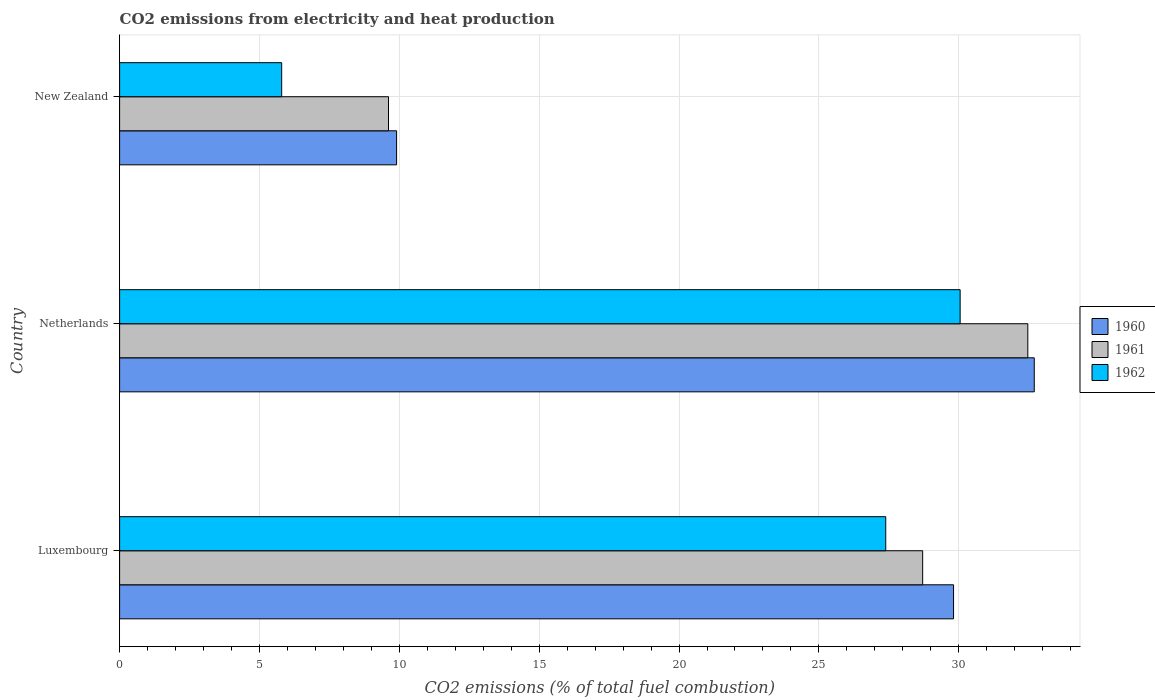How many bars are there on the 2nd tick from the top?
Make the answer very short. 3. What is the amount of CO2 emitted in 1960 in Netherlands?
Offer a very short reply. 32.7. Across all countries, what is the maximum amount of CO2 emitted in 1961?
Your answer should be very brief. 32.47. Across all countries, what is the minimum amount of CO2 emitted in 1962?
Make the answer very short. 5.79. In which country was the amount of CO2 emitted in 1962 minimum?
Make the answer very short. New Zealand. What is the total amount of CO2 emitted in 1962 in the graph?
Provide a short and direct response. 63.23. What is the difference between the amount of CO2 emitted in 1960 in Netherlands and that in New Zealand?
Your answer should be very brief. 22.8. What is the difference between the amount of CO2 emitted in 1960 in New Zealand and the amount of CO2 emitted in 1962 in Netherlands?
Your response must be concise. -20.15. What is the average amount of CO2 emitted in 1961 per country?
Provide a short and direct response. 23.6. What is the difference between the amount of CO2 emitted in 1962 and amount of CO2 emitted in 1960 in New Zealand?
Make the answer very short. -4.11. What is the ratio of the amount of CO2 emitted in 1960 in Netherlands to that in New Zealand?
Provide a short and direct response. 3.3. Is the difference between the amount of CO2 emitted in 1962 in Netherlands and New Zealand greater than the difference between the amount of CO2 emitted in 1960 in Netherlands and New Zealand?
Ensure brevity in your answer.  Yes. What is the difference between the highest and the second highest amount of CO2 emitted in 1960?
Your answer should be very brief. 2.89. What is the difference between the highest and the lowest amount of CO2 emitted in 1960?
Your response must be concise. 22.8. What does the 3rd bar from the top in New Zealand represents?
Make the answer very short. 1960. Is it the case that in every country, the sum of the amount of CO2 emitted in 1962 and amount of CO2 emitted in 1960 is greater than the amount of CO2 emitted in 1961?
Offer a terse response. Yes. How many bars are there?
Offer a terse response. 9. What is the difference between two consecutive major ticks on the X-axis?
Provide a short and direct response. 5. What is the title of the graph?
Make the answer very short. CO2 emissions from electricity and heat production. What is the label or title of the X-axis?
Keep it short and to the point. CO2 emissions (% of total fuel combustion). What is the label or title of the Y-axis?
Keep it short and to the point. Country. What is the CO2 emissions (% of total fuel combustion) of 1960 in Luxembourg?
Provide a short and direct response. 29.81. What is the CO2 emissions (% of total fuel combustion) in 1961 in Luxembourg?
Provide a succinct answer. 28.71. What is the CO2 emissions (% of total fuel combustion) in 1962 in Luxembourg?
Provide a short and direct response. 27.39. What is the CO2 emissions (% of total fuel combustion) in 1960 in Netherlands?
Make the answer very short. 32.7. What is the CO2 emissions (% of total fuel combustion) of 1961 in Netherlands?
Provide a succinct answer. 32.47. What is the CO2 emissions (% of total fuel combustion) of 1962 in Netherlands?
Provide a short and direct response. 30.05. What is the CO2 emissions (% of total fuel combustion) in 1960 in New Zealand?
Ensure brevity in your answer.  9.9. What is the CO2 emissions (% of total fuel combustion) of 1961 in New Zealand?
Ensure brevity in your answer.  9.61. What is the CO2 emissions (% of total fuel combustion) of 1962 in New Zealand?
Your response must be concise. 5.79. Across all countries, what is the maximum CO2 emissions (% of total fuel combustion) of 1960?
Keep it short and to the point. 32.7. Across all countries, what is the maximum CO2 emissions (% of total fuel combustion) in 1961?
Provide a short and direct response. 32.47. Across all countries, what is the maximum CO2 emissions (% of total fuel combustion) in 1962?
Provide a succinct answer. 30.05. Across all countries, what is the minimum CO2 emissions (% of total fuel combustion) in 1960?
Make the answer very short. 9.9. Across all countries, what is the minimum CO2 emissions (% of total fuel combustion) of 1961?
Give a very brief answer. 9.61. Across all countries, what is the minimum CO2 emissions (% of total fuel combustion) of 1962?
Offer a very short reply. 5.79. What is the total CO2 emissions (% of total fuel combustion) of 1960 in the graph?
Your response must be concise. 72.42. What is the total CO2 emissions (% of total fuel combustion) in 1961 in the graph?
Provide a succinct answer. 70.79. What is the total CO2 emissions (% of total fuel combustion) in 1962 in the graph?
Provide a succinct answer. 63.23. What is the difference between the CO2 emissions (% of total fuel combustion) of 1960 in Luxembourg and that in Netherlands?
Your response must be concise. -2.89. What is the difference between the CO2 emissions (% of total fuel combustion) of 1961 in Luxembourg and that in Netherlands?
Your response must be concise. -3.76. What is the difference between the CO2 emissions (% of total fuel combustion) in 1962 in Luxembourg and that in Netherlands?
Provide a succinct answer. -2.66. What is the difference between the CO2 emissions (% of total fuel combustion) of 1960 in Luxembourg and that in New Zealand?
Provide a short and direct response. 19.91. What is the difference between the CO2 emissions (% of total fuel combustion) in 1961 in Luxembourg and that in New Zealand?
Your response must be concise. 19.1. What is the difference between the CO2 emissions (% of total fuel combustion) of 1962 in Luxembourg and that in New Zealand?
Your response must be concise. 21.6. What is the difference between the CO2 emissions (% of total fuel combustion) in 1960 in Netherlands and that in New Zealand?
Offer a very short reply. 22.8. What is the difference between the CO2 emissions (% of total fuel combustion) of 1961 in Netherlands and that in New Zealand?
Ensure brevity in your answer.  22.86. What is the difference between the CO2 emissions (% of total fuel combustion) in 1962 in Netherlands and that in New Zealand?
Make the answer very short. 24.26. What is the difference between the CO2 emissions (% of total fuel combustion) in 1960 in Luxembourg and the CO2 emissions (% of total fuel combustion) in 1961 in Netherlands?
Offer a very short reply. -2.66. What is the difference between the CO2 emissions (% of total fuel combustion) in 1960 in Luxembourg and the CO2 emissions (% of total fuel combustion) in 1962 in Netherlands?
Your response must be concise. -0.24. What is the difference between the CO2 emissions (% of total fuel combustion) of 1961 in Luxembourg and the CO2 emissions (% of total fuel combustion) of 1962 in Netherlands?
Provide a short and direct response. -1.34. What is the difference between the CO2 emissions (% of total fuel combustion) in 1960 in Luxembourg and the CO2 emissions (% of total fuel combustion) in 1961 in New Zealand?
Offer a very short reply. 20.2. What is the difference between the CO2 emissions (% of total fuel combustion) of 1960 in Luxembourg and the CO2 emissions (% of total fuel combustion) of 1962 in New Zealand?
Make the answer very short. 24.02. What is the difference between the CO2 emissions (% of total fuel combustion) in 1961 in Luxembourg and the CO2 emissions (% of total fuel combustion) in 1962 in New Zealand?
Your answer should be very brief. 22.92. What is the difference between the CO2 emissions (% of total fuel combustion) of 1960 in Netherlands and the CO2 emissions (% of total fuel combustion) of 1961 in New Zealand?
Give a very brief answer. 23.09. What is the difference between the CO2 emissions (% of total fuel combustion) of 1960 in Netherlands and the CO2 emissions (% of total fuel combustion) of 1962 in New Zealand?
Your response must be concise. 26.91. What is the difference between the CO2 emissions (% of total fuel combustion) in 1961 in Netherlands and the CO2 emissions (% of total fuel combustion) in 1962 in New Zealand?
Keep it short and to the point. 26.68. What is the average CO2 emissions (% of total fuel combustion) in 1960 per country?
Offer a very short reply. 24.14. What is the average CO2 emissions (% of total fuel combustion) of 1961 per country?
Ensure brevity in your answer.  23.6. What is the average CO2 emissions (% of total fuel combustion) in 1962 per country?
Your response must be concise. 21.08. What is the difference between the CO2 emissions (% of total fuel combustion) in 1960 and CO2 emissions (% of total fuel combustion) in 1961 in Luxembourg?
Provide a succinct answer. 1.1. What is the difference between the CO2 emissions (% of total fuel combustion) in 1960 and CO2 emissions (% of total fuel combustion) in 1962 in Luxembourg?
Your response must be concise. 2.42. What is the difference between the CO2 emissions (% of total fuel combustion) in 1961 and CO2 emissions (% of total fuel combustion) in 1962 in Luxembourg?
Keep it short and to the point. 1.32. What is the difference between the CO2 emissions (% of total fuel combustion) in 1960 and CO2 emissions (% of total fuel combustion) in 1961 in Netherlands?
Your response must be concise. 0.23. What is the difference between the CO2 emissions (% of total fuel combustion) of 1960 and CO2 emissions (% of total fuel combustion) of 1962 in Netherlands?
Your response must be concise. 2.65. What is the difference between the CO2 emissions (% of total fuel combustion) in 1961 and CO2 emissions (% of total fuel combustion) in 1962 in Netherlands?
Ensure brevity in your answer.  2.42. What is the difference between the CO2 emissions (% of total fuel combustion) in 1960 and CO2 emissions (% of total fuel combustion) in 1961 in New Zealand?
Provide a short and direct response. 0.29. What is the difference between the CO2 emissions (% of total fuel combustion) of 1960 and CO2 emissions (% of total fuel combustion) of 1962 in New Zealand?
Keep it short and to the point. 4.11. What is the difference between the CO2 emissions (% of total fuel combustion) in 1961 and CO2 emissions (% of total fuel combustion) in 1962 in New Zealand?
Offer a very short reply. 3.82. What is the ratio of the CO2 emissions (% of total fuel combustion) of 1960 in Luxembourg to that in Netherlands?
Offer a terse response. 0.91. What is the ratio of the CO2 emissions (% of total fuel combustion) of 1961 in Luxembourg to that in Netherlands?
Provide a short and direct response. 0.88. What is the ratio of the CO2 emissions (% of total fuel combustion) of 1962 in Luxembourg to that in Netherlands?
Give a very brief answer. 0.91. What is the ratio of the CO2 emissions (% of total fuel combustion) in 1960 in Luxembourg to that in New Zealand?
Offer a very short reply. 3.01. What is the ratio of the CO2 emissions (% of total fuel combustion) of 1961 in Luxembourg to that in New Zealand?
Provide a short and direct response. 2.99. What is the ratio of the CO2 emissions (% of total fuel combustion) of 1962 in Luxembourg to that in New Zealand?
Provide a succinct answer. 4.73. What is the ratio of the CO2 emissions (% of total fuel combustion) of 1960 in Netherlands to that in New Zealand?
Give a very brief answer. 3.3. What is the ratio of the CO2 emissions (% of total fuel combustion) of 1961 in Netherlands to that in New Zealand?
Make the answer very short. 3.38. What is the ratio of the CO2 emissions (% of total fuel combustion) of 1962 in Netherlands to that in New Zealand?
Make the answer very short. 5.19. What is the difference between the highest and the second highest CO2 emissions (% of total fuel combustion) in 1960?
Offer a terse response. 2.89. What is the difference between the highest and the second highest CO2 emissions (% of total fuel combustion) of 1961?
Give a very brief answer. 3.76. What is the difference between the highest and the second highest CO2 emissions (% of total fuel combustion) in 1962?
Your answer should be very brief. 2.66. What is the difference between the highest and the lowest CO2 emissions (% of total fuel combustion) in 1960?
Offer a terse response. 22.8. What is the difference between the highest and the lowest CO2 emissions (% of total fuel combustion) of 1961?
Your answer should be compact. 22.86. What is the difference between the highest and the lowest CO2 emissions (% of total fuel combustion) of 1962?
Your response must be concise. 24.26. 